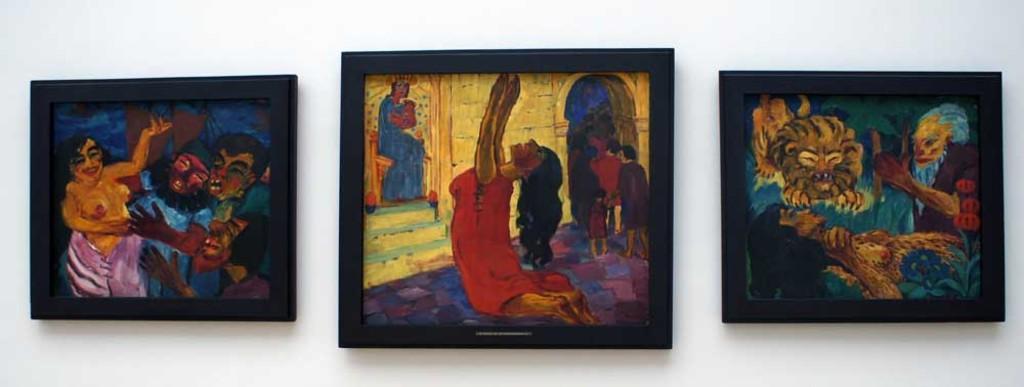Could you give a brief overview of what you see in this image? In this image we can see some photo frames on a wall. In that we can see the painting. 